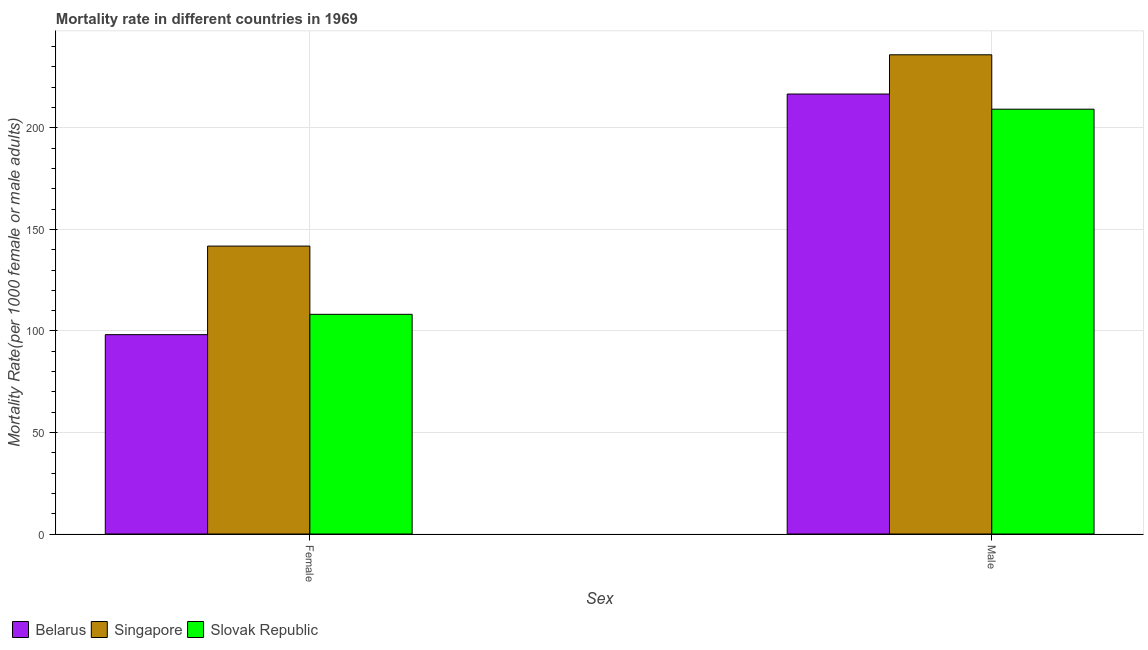How many different coloured bars are there?
Provide a succinct answer. 3. Are the number of bars on each tick of the X-axis equal?
Your response must be concise. Yes. How many bars are there on the 2nd tick from the left?
Give a very brief answer. 3. What is the label of the 1st group of bars from the left?
Keep it short and to the point. Female. What is the male mortality rate in Singapore?
Your response must be concise. 236. Across all countries, what is the maximum male mortality rate?
Ensure brevity in your answer.  236. Across all countries, what is the minimum female mortality rate?
Keep it short and to the point. 98.18. In which country was the male mortality rate maximum?
Make the answer very short. Singapore. In which country was the male mortality rate minimum?
Offer a terse response. Slovak Republic. What is the total female mortality rate in the graph?
Make the answer very short. 348.16. What is the difference between the female mortality rate in Singapore and that in Belarus?
Your answer should be very brief. 43.62. What is the difference between the male mortality rate in Slovak Republic and the female mortality rate in Singapore?
Make the answer very short. 67.42. What is the average female mortality rate per country?
Ensure brevity in your answer.  116.05. What is the difference between the male mortality rate and female mortality rate in Slovak Republic?
Offer a terse response. 101.03. What is the ratio of the male mortality rate in Slovak Republic to that in Belarus?
Make the answer very short. 0.97. Is the male mortality rate in Singapore less than that in Slovak Republic?
Your response must be concise. No. In how many countries, is the female mortality rate greater than the average female mortality rate taken over all countries?
Make the answer very short. 1. What does the 1st bar from the left in Male represents?
Your answer should be compact. Belarus. What does the 1st bar from the right in Male represents?
Ensure brevity in your answer.  Slovak Republic. How many countries are there in the graph?
Make the answer very short. 3. What is the difference between two consecutive major ticks on the Y-axis?
Provide a succinct answer. 50. Are the values on the major ticks of Y-axis written in scientific E-notation?
Your answer should be compact. No. Does the graph contain any zero values?
Provide a short and direct response. No. Where does the legend appear in the graph?
Offer a very short reply. Bottom left. How are the legend labels stacked?
Provide a short and direct response. Horizontal. What is the title of the graph?
Your response must be concise. Mortality rate in different countries in 1969. Does "Mozambique" appear as one of the legend labels in the graph?
Your answer should be compact. No. What is the label or title of the X-axis?
Provide a short and direct response. Sex. What is the label or title of the Y-axis?
Your answer should be very brief. Mortality Rate(per 1000 female or male adults). What is the Mortality Rate(per 1000 female or male adults) of Belarus in Female?
Offer a very short reply. 98.18. What is the Mortality Rate(per 1000 female or male adults) in Singapore in Female?
Ensure brevity in your answer.  141.8. What is the Mortality Rate(per 1000 female or male adults) of Slovak Republic in Female?
Provide a short and direct response. 108.19. What is the Mortality Rate(per 1000 female or male adults) in Belarus in Male?
Your answer should be compact. 216.68. What is the Mortality Rate(per 1000 female or male adults) of Singapore in Male?
Your answer should be compact. 236. What is the Mortality Rate(per 1000 female or male adults) in Slovak Republic in Male?
Provide a succinct answer. 209.22. Across all Sex, what is the maximum Mortality Rate(per 1000 female or male adults) of Belarus?
Keep it short and to the point. 216.68. Across all Sex, what is the maximum Mortality Rate(per 1000 female or male adults) in Singapore?
Your answer should be very brief. 236. Across all Sex, what is the maximum Mortality Rate(per 1000 female or male adults) of Slovak Republic?
Provide a short and direct response. 209.22. Across all Sex, what is the minimum Mortality Rate(per 1000 female or male adults) of Belarus?
Ensure brevity in your answer.  98.18. Across all Sex, what is the minimum Mortality Rate(per 1000 female or male adults) in Singapore?
Your response must be concise. 141.8. Across all Sex, what is the minimum Mortality Rate(per 1000 female or male adults) in Slovak Republic?
Ensure brevity in your answer.  108.19. What is the total Mortality Rate(per 1000 female or male adults) of Belarus in the graph?
Keep it short and to the point. 314.86. What is the total Mortality Rate(per 1000 female or male adults) in Singapore in the graph?
Your answer should be compact. 377.8. What is the total Mortality Rate(per 1000 female or male adults) in Slovak Republic in the graph?
Your answer should be very brief. 317.41. What is the difference between the Mortality Rate(per 1000 female or male adults) in Belarus in Female and that in Male?
Your answer should be very brief. -118.5. What is the difference between the Mortality Rate(per 1000 female or male adults) in Singapore in Female and that in Male?
Provide a succinct answer. -94.21. What is the difference between the Mortality Rate(per 1000 female or male adults) of Slovak Republic in Female and that in Male?
Provide a short and direct response. -101.03. What is the difference between the Mortality Rate(per 1000 female or male adults) of Belarus in Female and the Mortality Rate(per 1000 female or male adults) of Singapore in Male?
Your answer should be compact. -137.83. What is the difference between the Mortality Rate(per 1000 female or male adults) in Belarus in Female and the Mortality Rate(per 1000 female or male adults) in Slovak Republic in Male?
Offer a very short reply. -111.04. What is the difference between the Mortality Rate(per 1000 female or male adults) in Singapore in Female and the Mortality Rate(per 1000 female or male adults) in Slovak Republic in Male?
Offer a very short reply. -67.42. What is the average Mortality Rate(per 1000 female or male adults) of Belarus per Sex?
Your response must be concise. 157.43. What is the average Mortality Rate(per 1000 female or male adults) in Singapore per Sex?
Ensure brevity in your answer.  188.9. What is the average Mortality Rate(per 1000 female or male adults) in Slovak Republic per Sex?
Your answer should be very brief. 158.7. What is the difference between the Mortality Rate(per 1000 female or male adults) in Belarus and Mortality Rate(per 1000 female or male adults) in Singapore in Female?
Your answer should be very brief. -43.62. What is the difference between the Mortality Rate(per 1000 female or male adults) in Belarus and Mortality Rate(per 1000 female or male adults) in Slovak Republic in Female?
Provide a short and direct response. -10.01. What is the difference between the Mortality Rate(per 1000 female or male adults) of Singapore and Mortality Rate(per 1000 female or male adults) of Slovak Republic in Female?
Offer a terse response. 33.61. What is the difference between the Mortality Rate(per 1000 female or male adults) of Belarus and Mortality Rate(per 1000 female or male adults) of Singapore in Male?
Make the answer very short. -19.32. What is the difference between the Mortality Rate(per 1000 female or male adults) in Belarus and Mortality Rate(per 1000 female or male adults) in Slovak Republic in Male?
Your answer should be very brief. 7.47. What is the difference between the Mortality Rate(per 1000 female or male adults) of Singapore and Mortality Rate(per 1000 female or male adults) of Slovak Republic in Male?
Your answer should be very brief. 26.79. What is the ratio of the Mortality Rate(per 1000 female or male adults) of Belarus in Female to that in Male?
Give a very brief answer. 0.45. What is the ratio of the Mortality Rate(per 1000 female or male adults) in Singapore in Female to that in Male?
Your answer should be very brief. 0.6. What is the ratio of the Mortality Rate(per 1000 female or male adults) of Slovak Republic in Female to that in Male?
Provide a short and direct response. 0.52. What is the difference between the highest and the second highest Mortality Rate(per 1000 female or male adults) in Belarus?
Your response must be concise. 118.5. What is the difference between the highest and the second highest Mortality Rate(per 1000 female or male adults) of Singapore?
Ensure brevity in your answer.  94.21. What is the difference between the highest and the second highest Mortality Rate(per 1000 female or male adults) of Slovak Republic?
Your answer should be very brief. 101.03. What is the difference between the highest and the lowest Mortality Rate(per 1000 female or male adults) of Belarus?
Your answer should be very brief. 118.5. What is the difference between the highest and the lowest Mortality Rate(per 1000 female or male adults) of Singapore?
Provide a succinct answer. 94.21. What is the difference between the highest and the lowest Mortality Rate(per 1000 female or male adults) in Slovak Republic?
Ensure brevity in your answer.  101.03. 